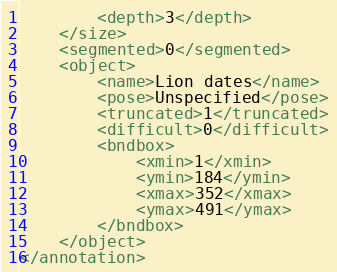<code> <loc_0><loc_0><loc_500><loc_500><_XML_>		<depth>3</depth>
	</size>
	<segmented>0</segmented>
	<object>
		<name>Lion dates</name>
		<pose>Unspecified</pose>
		<truncated>1</truncated>
		<difficult>0</difficult>
		<bndbox>
			<xmin>1</xmin>
			<ymin>184</ymin>
			<xmax>352</xmax>
			<ymax>491</ymax>
		</bndbox>
	</object>
</annotation>
</code> 